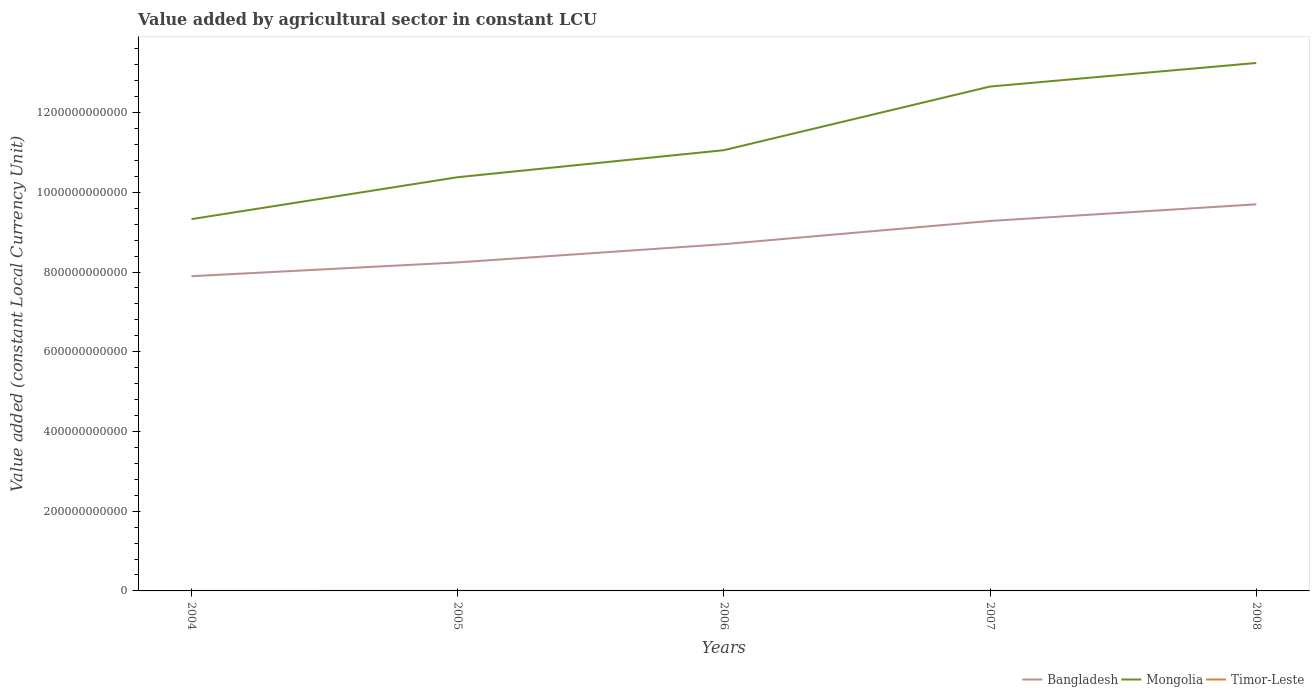Does the line corresponding to Bangladesh intersect with the line corresponding to Timor-Leste?
Your answer should be compact. No. Across all years, what is the maximum value added by agricultural sector in Bangladesh?
Your answer should be very brief. 7.89e+11. In which year was the value added by agricultural sector in Bangladesh maximum?
Give a very brief answer. 2004. What is the total value added by agricultural sector in Mongolia in the graph?
Your response must be concise. -3.92e+11. What is the difference between the highest and the second highest value added by agricultural sector in Mongolia?
Give a very brief answer. 3.92e+11. What is the difference between the highest and the lowest value added by agricultural sector in Bangladesh?
Give a very brief answer. 2. Is the value added by agricultural sector in Timor-Leste strictly greater than the value added by agricultural sector in Bangladesh over the years?
Offer a very short reply. Yes. How many lines are there?
Your answer should be very brief. 3. What is the difference between two consecutive major ticks on the Y-axis?
Offer a very short reply. 2.00e+11. Does the graph contain grids?
Give a very brief answer. No. How many legend labels are there?
Provide a succinct answer. 3. How are the legend labels stacked?
Offer a very short reply. Horizontal. What is the title of the graph?
Give a very brief answer. Value added by agricultural sector in constant LCU. What is the label or title of the Y-axis?
Offer a terse response. Value added (constant Local Currency Unit). What is the Value added (constant Local Currency Unit) in Bangladesh in 2004?
Offer a terse response. 7.89e+11. What is the Value added (constant Local Currency Unit) in Mongolia in 2004?
Offer a terse response. 9.33e+11. What is the Value added (constant Local Currency Unit) in Timor-Leste in 2004?
Ensure brevity in your answer.  1.71e+08. What is the Value added (constant Local Currency Unit) of Bangladesh in 2005?
Ensure brevity in your answer.  8.24e+11. What is the Value added (constant Local Currency Unit) of Mongolia in 2005?
Offer a very short reply. 1.04e+12. What is the Value added (constant Local Currency Unit) of Timor-Leste in 2005?
Your response must be concise. 1.78e+08. What is the Value added (constant Local Currency Unit) in Bangladesh in 2006?
Provide a succinct answer. 8.70e+11. What is the Value added (constant Local Currency Unit) of Mongolia in 2006?
Offer a terse response. 1.11e+12. What is the Value added (constant Local Currency Unit) of Timor-Leste in 2006?
Provide a short and direct response. 1.87e+08. What is the Value added (constant Local Currency Unit) in Bangladesh in 2007?
Your answer should be very brief. 9.28e+11. What is the Value added (constant Local Currency Unit) in Mongolia in 2007?
Your answer should be compact. 1.27e+12. What is the Value added (constant Local Currency Unit) in Timor-Leste in 2007?
Make the answer very short. 1.81e+08. What is the Value added (constant Local Currency Unit) in Bangladesh in 2008?
Your answer should be compact. 9.70e+11. What is the Value added (constant Local Currency Unit) in Mongolia in 2008?
Give a very brief answer. 1.32e+12. What is the Value added (constant Local Currency Unit) of Timor-Leste in 2008?
Give a very brief answer. 1.81e+08. Across all years, what is the maximum Value added (constant Local Currency Unit) of Bangladesh?
Ensure brevity in your answer.  9.70e+11. Across all years, what is the maximum Value added (constant Local Currency Unit) of Mongolia?
Give a very brief answer. 1.32e+12. Across all years, what is the maximum Value added (constant Local Currency Unit) of Timor-Leste?
Your answer should be very brief. 1.87e+08. Across all years, what is the minimum Value added (constant Local Currency Unit) in Bangladesh?
Ensure brevity in your answer.  7.89e+11. Across all years, what is the minimum Value added (constant Local Currency Unit) of Mongolia?
Your answer should be compact. 9.33e+11. Across all years, what is the minimum Value added (constant Local Currency Unit) of Timor-Leste?
Your response must be concise. 1.71e+08. What is the total Value added (constant Local Currency Unit) in Bangladesh in the graph?
Keep it short and to the point. 4.38e+12. What is the total Value added (constant Local Currency Unit) in Mongolia in the graph?
Your answer should be very brief. 5.67e+12. What is the total Value added (constant Local Currency Unit) of Timor-Leste in the graph?
Ensure brevity in your answer.  8.98e+08. What is the difference between the Value added (constant Local Currency Unit) in Bangladesh in 2004 and that in 2005?
Give a very brief answer. -3.46e+1. What is the difference between the Value added (constant Local Currency Unit) in Mongolia in 2004 and that in 2005?
Provide a succinct answer. -1.05e+11. What is the difference between the Value added (constant Local Currency Unit) of Timor-Leste in 2004 and that in 2005?
Make the answer very short. -7.00e+06. What is the difference between the Value added (constant Local Currency Unit) in Bangladesh in 2004 and that in 2006?
Ensure brevity in your answer.  -8.04e+1. What is the difference between the Value added (constant Local Currency Unit) of Mongolia in 2004 and that in 2006?
Your answer should be compact. -1.73e+11. What is the difference between the Value added (constant Local Currency Unit) of Timor-Leste in 2004 and that in 2006?
Offer a terse response. -1.60e+07. What is the difference between the Value added (constant Local Currency Unit) of Bangladesh in 2004 and that in 2007?
Offer a terse response. -1.39e+11. What is the difference between the Value added (constant Local Currency Unit) of Mongolia in 2004 and that in 2007?
Your response must be concise. -3.33e+11. What is the difference between the Value added (constant Local Currency Unit) in Timor-Leste in 2004 and that in 2007?
Your answer should be very brief. -1.00e+07. What is the difference between the Value added (constant Local Currency Unit) of Bangladesh in 2004 and that in 2008?
Give a very brief answer. -1.80e+11. What is the difference between the Value added (constant Local Currency Unit) in Mongolia in 2004 and that in 2008?
Ensure brevity in your answer.  -3.92e+11. What is the difference between the Value added (constant Local Currency Unit) in Timor-Leste in 2004 and that in 2008?
Your answer should be very brief. -1.00e+07. What is the difference between the Value added (constant Local Currency Unit) of Bangladesh in 2005 and that in 2006?
Keep it short and to the point. -4.58e+1. What is the difference between the Value added (constant Local Currency Unit) in Mongolia in 2005 and that in 2006?
Keep it short and to the point. -6.78e+1. What is the difference between the Value added (constant Local Currency Unit) in Timor-Leste in 2005 and that in 2006?
Your answer should be very brief. -9.00e+06. What is the difference between the Value added (constant Local Currency Unit) of Bangladesh in 2005 and that in 2007?
Keep it short and to the point. -1.04e+11. What is the difference between the Value added (constant Local Currency Unit) of Mongolia in 2005 and that in 2007?
Give a very brief answer. -2.27e+11. What is the difference between the Value added (constant Local Currency Unit) in Timor-Leste in 2005 and that in 2007?
Give a very brief answer. -3.00e+06. What is the difference between the Value added (constant Local Currency Unit) in Bangladesh in 2005 and that in 2008?
Your response must be concise. -1.46e+11. What is the difference between the Value added (constant Local Currency Unit) in Mongolia in 2005 and that in 2008?
Your response must be concise. -2.87e+11. What is the difference between the Value added (constant Local Currency Unit) of Timor-Leste in 2005 and that in 2008?
Your response must be concise. -3.00e+06. What is the difference between the Value added (constant Local Currency Unit) in Bangladesh in 2006 and that in 2007?
Offer a terse response. -5.82e+1. What is the difference between the Value added (constant Local Currency Unit) in Mongolia in 2006 and that in 2007?
Your answer should be very brief. -1.60e+11. What is the difference between the Value added (constant Local Currency Unit) of Timor-Leste in 2006 and that in 2007?
Offer a very short reply. 6.00e+06. What is the difference between the Value added (constant Local Currency Unit) in Bangladesh in 2006 and that in 2008?
Make the answer very short. -9.99e+1. What is the difference between the Value added (constant Local Currency Unit) in Mongolia in 2006 and that in 2008?
Offer a very short reply. -2.19e+11. What is the difference between the Value added (constant Local Currency Unit) in Timor-Leste in 2006 and that in 2008?
Provide a succinct answer. 6.00e+06. What is the difference between the Value added (constant Local Currency Unit) of Bangladesh in 2007 and that in 2008?
Make the answer very short. -4.17e+1. What is the difference between the Value added (constant Local Currency Unit) of Mongolia in 2007 and that in 2008?
Provide a short and direct response. -5.91e+1. What is the difference between the Value added (constant Local Currency Unit) in Bangladesh in 2004 and the Value added (constant Local Currency Unit) in Mongolia in 2005?
Make the answer very short. -2.48e+11. What is the difference between the Value added (constant Local Currency Unit) of Bangladesh in 2004 and the Value added (constant Local Currency Unit) of Timor-Leste in 2005?
Keep it short and to the point. 7.89e+11. What is the difference between the Value added (constant Local Currency Unit) in Mongolia in 2004 and the Value added (constant Local Currency Unit) in Timor-Leste in 2005?
Offer a very short reply. 9.32e+11. What is the difference between the Value added (constant Local Currency Unit) of Bangladesh in 2004 and the Value added (constant Local Currency Unit) of Mongolia in 2006?
Your answer should be compact. -3.16e+11. What is the difference between the Value added (constant Local Currency Unit) of Bangladesh in 2004 and the Value added (constant Local Currency Unit) of Timor-Leste in 2006?
Offer a terse response. 7.89e+11. What is the difference between the Value added (constant Local Currency Unit) of Mongolia in 2004 and the Value added (constant Local Currency Unit) of Timor-Leste in 2006?
Give a very brief answer. 9.32e+11. What is the difference between the Value added (constant Local Currency Unit) in Bangladesh in 2004 and the Value added (constant Local Currency Unit) in Mongolia in 2007?
Your answer should be compact. -4.76e+11. What is the difference between the Value added (constant Local Currency Unit) in Bangladesh in 2004 and the Value added (constant Local Currency Unit) in Timor-Leste in 2007?
Give a very brief answer. 7.89e+11. What is the difference between the Value added (constant Local Currency Unit) in Mongolia in 2004 and the Value added (constant Local Currency Unit) in Timor-Leste in 2007?
Your response must be concise. 9.32e+11. What is the difference between the Value added (constant Local Currency Unit) of Bangladesh in 2004 and the Value added (constant Local Currency Unit) of Mongolia in 2008?
Make the answer very short. -5.35e+11. What is the difference between the Value added (constant Local Currency Unit) of Bangladesh in 2004 and the Value added (constant Local Currency Unit) of Timor-Leste in 2008?
Offer a terse response. 7.89e+11. What is the difference between the Value added (constant Local Currency Unit) of Mongolia in 2004 and the Value added (constant Local Currency Unit) of Timor-Leste in 2008?
Your answer should be compact. 9.32e+11. What is the difference between the Value added (constant Local Currency Unit) in Bangladesh in 2005 and the Value added (constant Local Currency Unit) in Mongolia in 2006?
Provide a short and direct response. -2.82e+11. What is the difference between the Value added (constant Local Currency Unit) of Bangladesh in 2005 and the Value added (constant Local Currency Unit) of Timor-Leste in 2006?
Offer a very short reply. 8.24e+11. What is the difference between the Value added (constant Local Currency Unit) of Mongolia in 2005 and the Value added (constant Local Currency Unit) of Timor-Leste in 2006?
Give a very brief answer. 1.04e+12. What is the difference between the Value added (constant Local Currency Unit) of Bangladesh in 2005 and the Value added (constant Local Currency Unit) of Mongolia in 2007?
Offer a terse response. -4.41e+11. What is the difference between the Value added (constant Local Currency Unit) in Bangladesh in 2005 and the Value added (constant Local Currency Unit) in Timor-Leste in 2007?
Keep it short and to the point. 8.24e+11. What is the difference between the Value added (constant Local Currency Unit) in Mongolia in 2005 and the Value added (constant Local Currency Unit) in Timor-Leste in 2007?
Offer a very short reply. 1.04e+12. What is the difference between the Value added (constant Local Currency Unit) of Bangladesh in 2005 and the Value added (constant Local Currency Unit) of Mongolia in 2008?
Ensure brevity in your answer.  -5.00e+11. What is the difference between the Value added (constant Local Currency Unit) of Bangladesh in 2005 and the Value added (constant Local Currency Unit) of Timor-Leste in 2008?
Provide a short and direct response. 8.24e+11. What is the difference between the Value added (constant Local Currency Unit) in Mongolia in 2005 and the Value added (constant Local Currency Unit) in Timor-Leste in 2008?
Your response must be concise. 1.04e+12. What is the difference between the Value added (constant Local Currency Unit) in Bangladesh in 2006 and the Value added (constant Local Currency Unit) in Mongolia in 2007?
Provide a succinct answer. -3.95e+11. What is the difference between the Value added (constant Local Currency Unit) of Bangladesh in 2006 and the Value added (constant Local Currency Unit) of Timor-Leste in 2007?
Keep it short and to the point. 8.70e+11. What is the difference between the Value added (constant Local Currency Unit) in Mongolia in 2006 and the Value added (constant Local Currency Unit) in Timor-Leste in 2007?
Offer a terse response. 1.11e+12. What is the difference between the Value added (constant Local Currency Unit) of Bangladesh in 2006 and the Value added (constant Local Currency Unit) of Mongolia in 2008?
Give a very brief answer. -4.55e+11. What is the difference between the Value added (constant Local Currency Unit) of Bangladesh in 2006 and the Value added (constant Local Currency Unit) of Timor-Leste in 2008?
Your response must be concise. 8.70e+11. What is the difference between the Value added (constant Local Currency Unit) of Mongolia in 2006 and the Value added (constant Local Currency Unit) of Timor-Leste in 2008?
Your response must be concise. 1.11e+12. What is the difference between the Value added (constant Local Currency Unit) of Bangladesh in 2007 and the Value added (constant Local Currency Unit) of Mongolia in 2008?
Keep it short and to the point. -3.96e+11. What is the difference between the Value added (constant Local Currency Unit) of Bangladesh in 2007 and the Value added (constant Local Currency Unit) of Timor-Leste in 2008?
Your response must be concise. 9.28e+11. What is the difference between the Value added (constant Local Currency Unit) of Mongolia in 2007 and the Value added (constant Local Currency Unit) of Timor-Leste in 2008?
Your answer should be very brief. 1.27e+12. What is the average Value added (constant Local Currency Unit) in Bangladesh per year?
Make the answer very short. 8.76e+11. What is the average Value added (constant Local Currency Unit) of Mongolia per year?
Your answer should be very brief. 1.13e+12. What is the average Value added (constant Local Currency Unit) of Timor-Leste per year?
Offer a terse response. 1.80e+08. In the year 2004, what is the difference between the Value added (constant Local Currency Unit) of Bangladesh and Value added (constant Local Currency Unit) of Mongolia?
Ensure brevity in your answer.  -1.43e+11. In the year 2004, what is the difference between the Value added (constant Local Currency Unit) of Bangladesh and Value added (constant Local Currency Unit) of Timor-Leste?
Your answer should be compact. 7.89e+11. In the year 2004, what is the difference between the Value added (constant Local Currency Unit) of Mongolia and Value added (constant Local Currency Unit) of Timor-Leste?
Give a very brief answer. 9.32e+11. In the year 2005, what is the difference between the Value added (constant Local Currency Unit) in Bangladesh and Value added (constant Local Currency Unit) in Mongolia?
Give a very brief answer. -2.14e+11. In the year 2005, what is the difference between the Value added (constant Local Currency Unit) in Bangladesh and Value added (constant Local Currency Unit) in Timor-Leste?
Provide a succinct answer. 8.24e+11. In the year 2005, what is the difference between the Value added (constant Local Currency Unit) in Mongolia and Value added (constant Local Currency Unit) in Timor-Leste?
Offer a very short reply. 1.04e+12. In the year 2006, what is the difference between the Value added (constant Local Currency Unit) of Bangladesh and Value added (constant Local Currency Unit) of Mongolia?
Provide a short and direct response. -2.36e+11. In the year 2006, what is the difference between the Value added (constant Local Currency Unit) of Bangladesh and Value added (constant Local Currency Unit) of Timor-Leste?
Your answer should be compact. 8.70e+11. In the year 2006, what is the difference between the Value added (constant Local Currency Unit) of Mongolia and Value added (constant Local Currency Unit) of Timor-Leste?
Keep it short and to the point. 1.11e+12. In the year 2007, what is the difference between the Value added (constant Local Currency Unit) in Bangladesh and Value added (constant Local Currency Unit) in Mongolia?
Offer a very short reply. -3.37e+11. In the year 2007, what is the difference between the Value added (constant Local Currency Unit) in Bangladesh and Value added (constant Local Currency Unit) in Timor-Leste?
Provide a succinct answer. 9.28e+11. In the year 2007, what is the difference between the Value added (constant Local Currency Unit) in Mongolia and Value added (constant Local Currency Unit) in Timor-Leste?
Keep it short and to the point. 1.27e+12. In the year 2008, what is the difference between the Value added (constant Local Currency Unit) of Bangladesh and Value added (constant Local Currency Unit) of Mongolia?
Give a very brief answer. -3.55e+11. In the year 2008, what is the difference between the Value added (constant Local Currency Unit) of Bangladesh and Value added (constant Local Currency Unit) of Timor-Leste?
Give a very brief answer. 9.70e+11. In the year 2008, what is the difference between the Value added (constant Local Currency Unit) of Mongolia and Value added (constant Local Currency Unit) of Timor-Leste?
Provide a succinct answer. 1.32e+12. What is the ratio of the Value added (constant Local Currency Unit) in Bangladesh in 2004 to that in 2005?
Offer a very short reply. 0.96. What is the ratio of the Value added (constant Local Currency Unit) of Mongolia in 2004 to that in 2005?
Provide a succinct answer. 0.9. What is the ratio of the Value added (constant Local Currency Unit) in Timor-Leste in 2004 to that in 2005?
Your answer should be very brief. 0.96. What is the ratio of the Value added (constant Local Currency Unit) in Bangladesh in 2004 to that in 2006?
Ensure brevity in your answer.  0.91. What is the ratio of the Value added (constant Local Currency Unit) in Mongolia in 2004 to that in 2006?
Make the answer very short. 0.84. What is the ratio of the Value added (constant Local Currency Unit) in Timor-Leste in 2004 to that in 2006?
Provide a succinct answer. 0.91. What is the ratio of the Value added (constant Local Currency Unit) of Bangladesh in 2004 to that in 2007?
Ensure brevity in your answer.  0.85. What is the ratio of the Value added (constant Local Currency Unit) of Mongolia in 2004 to that in 2007?
Ensure brevity in your answer.  0.74. What is the ratio of the Value added (constant Local Currency Unit) of Timor-Leste in 2004 to that in 2007?
Offer a very short reply. 0.94. What is the ratio of the Value added (constant Local Currency Unit) of Bangladesh in 2004 to that in 2008?
Offer a very short reply. 0.81. What is the ratio of the Value added (constant Local Currency Unit) of Mongolia in 2004 to that in 2008?
Offer a very short reply. 0.7. What is the ratio of the Value added (constant Local Currency Unit) of Timor-Leste in 2004 to that in 2008?
Your answer should be very brief. 0.94. What is the ratio of the Value added (constant Local Currency Unit) in Mongolia in 2005 to that in 2006?
Your answer should be very brief. 0.94. What is the ratio of the Value added (constant Local Currency Unit) of Timor-Leste in 2005 to that in 2006?
Offer a very short reply. 0.95. What is the ratio of the Value added (constant Local Currency Unit) of Bangladesh in 2005 to that in 2007?
Make the answer very short. 0.89. What is the ratio of the Value added (constant Local Currency Unit) of Mongolia in 2005 to that in 2007?
Offer a terse response. 0.82. What is the ratio of the Value added (constant Local Currency Unit) in Timor-Leste in 2005 to that in 2007?
Make the answer very short. 0.98. What is the ratio of the Value added (constant Local Currency Unit) in Bangladesh in 2005 to that in 2008?
Provide a short and direct response. 0.85. What is the ratio of the Value added (constant Local Currency Unit) in Mongolia in 2005 to that in 2008?
Make the answer very short. 0.78. What is the ratio of the Value added (constant Local Currency Unit) of Timor-Leste in 2005 to that in 2008?
Provide a succinct answer. 0.98. What is the ratio of the Value added (constant Local Currency Unit) in Bangladesh in 2006 to that in 2007?
Your response must be concise. 0.94. What is the ratio of the Value added (constant Local Currency Unit) of Mongolia in 2006 to that in 2007?
Keep it short and to the point. 0.87. What is the ratio of the Value added (constant Local Currency Unit) of Timor-Leste in 2006 to that in 2007?
Ensure brevity in your answer.  1.03. What is the ratio of the Value added (constant Local Currency Unit) in Bangladesh in 2006 to that in 2008?
Keep it short and to the point. 0.9. What is the ratio of the Value added (constant Local Currency Unit) in Mongolia in 2006 to that in 2008?
Provide a short and direct response. 0.83. What is the ratio of the Value added (constant Local Currency Unit) in Timor-Leste in 2006 to that in 2008?
Your answer should be compact. 1.03. What is the ratio of the Value added (constant Local Currency Unit) of Mongolia in 2007 to that in 2008?
Offer a very short reply. 0.96. What is the ratio of the Value added (constant Local Currency Unit) of Timor-Leste in 2007 to that in 2008?
Your answer should be compact. 1. What is the difference between the highest and the second highest Value added (constant Local Currency Unit) of Bangladesh?
Offer a very short reply. 4.17e+1. What is the difference between the highest and the second highest Value added (constant Local Currency Unit) of Mongolia?
Provide a short and direct response. 5.91e+1. What is the difference between the highest and the second highest Value added (constant Local Currency Unit) of Timor-Leste?
Offer a terse response. 6.00e+06. What is the difference between the highest and the lowest Value added (constant Local Currency Unit) in Bangladesh?
Offer a terse response. 1.80e+11. What is the difference between the highest and the lowest Value added (constant Local Currency Unit) of Mongolia?
Provide a succinct answer. 3.92e+11. What is the difference between the highest and the lowest Value added (constant Local Currency Unit) in Timor-Leste?
Offer a very short reply. 1.60e+07. 